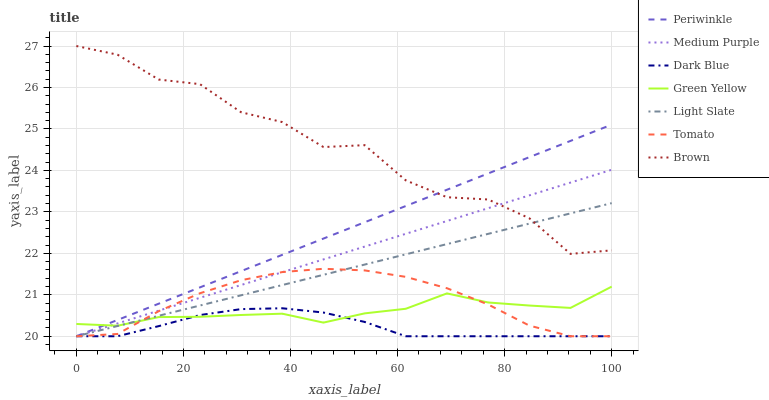Does Dark Blue have the minimum area under the curve?
Answer yes or no. Yes. Does Brown have the maximum area under the curve?
Answer yes or no. Yes. Does Light Slate have the minimum area under the curve?
Answer yes or no. No. Does Light Slate have the maximum area under the curve?
Answer yes or no. No. Is Periwinkle the smoothest?
Answer yes or no. Yes. Is Brown the roughest?
Answer yes or no. Yes. Is Light Slate the smoothest?
Answer yes or no. No. Is Light Slate the roughest?
Answer yes or no. No. Does Brown have the lowest value?
Answer yes or no. No. Does Brown have the highest value?
Answer yes or no. Yes. Does Light Slate have the highest value?
Answer yes or no. No. Is Green Yellow less than Brown?
Answer yes or no. Yes. Is Brown greater than Tomato?
Answer yes or no. Yes. Does Periwinkle intersect Brown?
Answer yes or no. Yes. Is Periwinkle less than Brown?
Answer yes or no. No. Is Periwinkle greater than Brown?
Answer yes or no. No. Does Green Yellow intersect Brown?
Answer yes or no. No. 